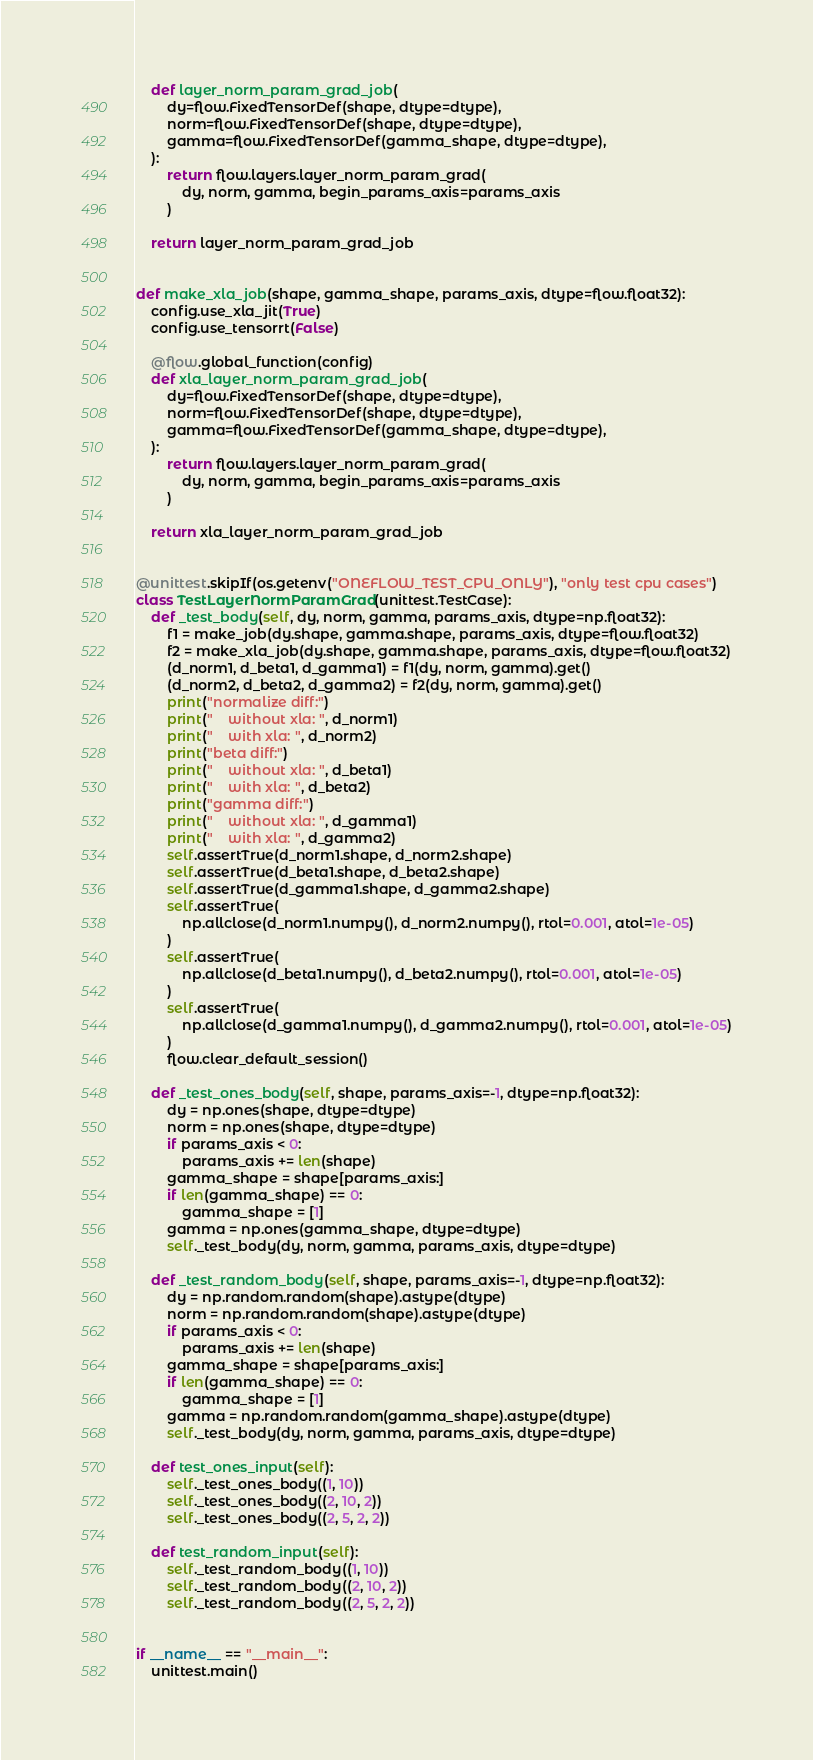<code> <loc_0><loc_0><loc_500><loc_500><_Python_>    def layer_norm_param_grad_job(
        dy=flow.FixedTensorDef(shape, dtype=dtype),
        norm=flow.FixedTensorDef(shape, dtype=dtype),
        gamma=flow.FixedTensorDef(gamma_shape, dtype=dtype),
    ):
        return flow.layers.layer_norm_param_grad(
            dy, norm, gamma, begin_params_axis=params_axis
        )

    return layer_norm_param_grad_job


def make_xla_job(shape, gamma_shape, params_axis, dtype=flow.float32):
    config.use_xla_jit(True)
    config.use_tensorrt(False)

    @flow.global_function(config)
    def xla_layer_norm_param_grad_job(
        dy=flow.FixedTensorDef(shape, dtype=dtype),
        norm=flow.FixedTensorDef(shape, dtype=dtype),
        gamma=flow.FixedTensorDef(gamma_shape, dtype=dtype),
    ):
        return flow.layers.layer_norm_param_grad(
            dy, norm, gamma, begin_params_axis=params_axis
        )

    return xla_layer_norm_param_grad_job


@unittest.skipIf(os.getenv("ONEFLOW_TEST_CPU_ONLY"), "only test cpu cases")
class TestLayerNormParamGrad(unittest.TestCase):
    def _test_body(self, dy, norm, gamma, params_axis, dtype=np.float32):
        f1 = make_job(dy.shape, gamma.shape, params_axis, dtype=flow.float32)
        f2 = make_xla_job(dy.shape, gamma.shape, params_axis, dtype=flow.float32)
        (d_norm1, d_beta1, d_gamma1) = f1(dy, norm, gamma).get()
        (d_norm2, d_beta2, d_gamma2) = f2(dy, norm, gamma).get()
        print("normalize diff:")
        print("    without xla: ", d_norm1)
        print("    with xla: ", d_norm2)
        print("beta diff:")
        print("    without xla: ", d_beta1)
        print("    with xla: ", d_beta2)
        print("gamma diff:")
        print("    without xla: ", d_gamma1)
        print("    with xla: ", d_gamma2)
        self.assertTrue(d_norm1.shape, d_norm2.shape)
        self.assertTrue(d_beta1.shape, d_beta2.shape)
        self.assertTrue(d_gamma1.shape, d_gamma2.shape)
        self.assertTrue(
            np.allclose(d_norm1.numpy(), d_norm2.numpy(), rtol=0.001, atol=1e-05)
        )
        self.assertTrue(
            np.allclose(d_beta1.numpy(), d_beta2.numpy(), rtol=0.001, atol=1e-05)
        )
        self.assertTrue(
            np.allclose(d_gamma1.numpy(), d_gamma2.numpy(), rtol=0.001, atol=1e-05)
        )
        flow.clear_default_session()

    def _test_ones_body(self, shape, params_axis=-1, dtype=np.float32):
        dy = np.ones(shape, dtype=dtype)
        norm = np.ones(shape, dtype=dtype)
        if params_axis < 0:
            params_axis += len(shape)
        gamma_shape = shape[params_axis:]
        if len(gamma_shape) == 0:
            gamma_shape = [1]
        gamma = np.ones(gamma_shape, dtype=dtype)
        self._test_body(dy, norm, gamma, params_axis, dtype=dtype)

    def _test_random_body(self, shape, params_axis=-1, dtype=np.float32):
        dy = np.random.random(shape).astype(dtype)
        norm = np.random.random(shape).astype(dtype)
        if params_axis < 0:
            params_axis += len(shape)
        gamma_shape = shape[params_axis:]
        if len(gamma_shape) == 0:
            gamma_shape = [1]
        gamma = np.random.random(gamma_shape).astype(dtype)
        self._test_body(dy, norm, gamma, params_axis, dtype=dtype)

    def test_ones_input(self):
        self._test_ones_body((1, 10))
        self._test_ones_body((2, 10, 2))
        self._test_ones_body((2, 5, 2, 2))

    def test_random_input(self):
        self._test_random_body((1, 10))
        self._test_random_body((2, 10, 2))
        self._test_random_body((2, 5, 2, 2))


if __name__ == "__main__":
    unittest.main()
</code> 